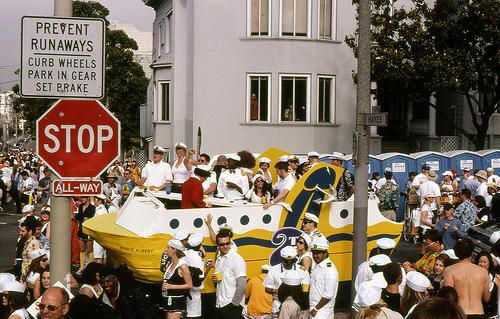What type of building is seen in the background of the image? There is a gray building in the background. What is the color of the stop sign in the image? The stop sign is red. Identify the primary object placed above the stop sign. There is a black and white street sign above the stop sign. What is directly below the stop sign in the image? A red and white all-way sign is located below the stop sign. Is there any person not wearing a shirt in the image? If yes, what color are their shorts? Yes, there is a topless man who is wearing black shorts. What color are the portable bathrooms seen in the image? The portable bathrooms are blue. What are the people dressed up in on the boat float at the parade? People on the boat float are dressed up in sailor outfits. What type of float is shown at the parade in the image? There is a blue, white, and yellow cruise ship float at the parade. Please describe the crowd of people in the image. There is a large crowd of people gathered at a parade, some are riding on a float designed like a boat, and others are standing around watching the festivities. Describe the hat worn by a person in the image. There is a person wearing a white hat on their head. Identify the crowd of people dressed in pirate outfits. The instruction is misleading as the people are dressed in sailor outfits, not pirate outfits. The word "go" is written on the stop sign. This is misleading as the word on the stop sign is actually "stop," not "go." Is the stop sign mounted on a tree instead of a pole? The instruction implies that the stop sign is mounted on a tree, while in the actual image, it is mounted on a pole. The person with glasses is wearing a yellow hat. This is misleading as the person is wearing a white hat, not a yellow one. Is the sky bright and sunny? This instruction is misleading because the sky is described as grey, not bright and sunny. The person with a red shirt is wearing a green tie. No, it's not mentioned in the image. Find a pink boat float in the parade. This instruction is incorrect because the boat float is described as blue, white, and yellow, not pink. Look for a green and white all way sign below the stop sign. The instruction is misleading because there is a red and white all way sign in the image, not a green one. Are there purple outhouses in the background? The instruction is not accurate because the outhouses in the background are blue, not purple. The building in the background has a colorful mural painted on it. This instruction is misleading because the building is described as gray, not having a colorful mural. 